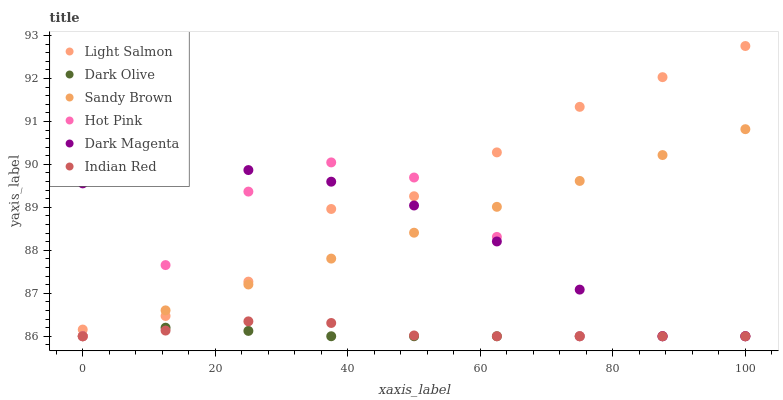Does Dark Olive have the minimum area under the curve?
Answer yes or no. Yes. Does Light Salmon have the maximum area under the curve?
Answer yes or no. Yes. Does Hot Pink have the minimum area under the curve?
Answer yes or no. No. Does Hot Pink have the maximum area under the curve?
Answer yes or no. No. Is Sandy Brown the smoothest?
Answer yes or no. Yes. Is Hot Pink the roughest?
Answer yes or no. Yes. Is Dark Magenta the smoothest?
Answer yes or no. No. Is Dark Magenta the roughest?
Answer yes or no. No. Does Hot Pink have the lowest value?
Answer yes or no. Yes. Does Light Salmon have the highest value?
Answer yes or no. Yes. Does Hot Pink have the highest value?
Answer yes or no. No. Is Indian Red less than Light Salmon?
Answer yes or no. Yes. Is Light Salmon greater than Dark Olive?
Answer yes or no. Yes. Does Indian Red intersect Dark Magenta?
Answer yes or no. Yes. Is Indian Red less than Dark Magenta?
Answer yes or no. No. Is Indian Red greater than Dark Magenta?
Answer yes or no. No. Does Indian Red intersect Light Salmon?
Answer yes or no. No. 